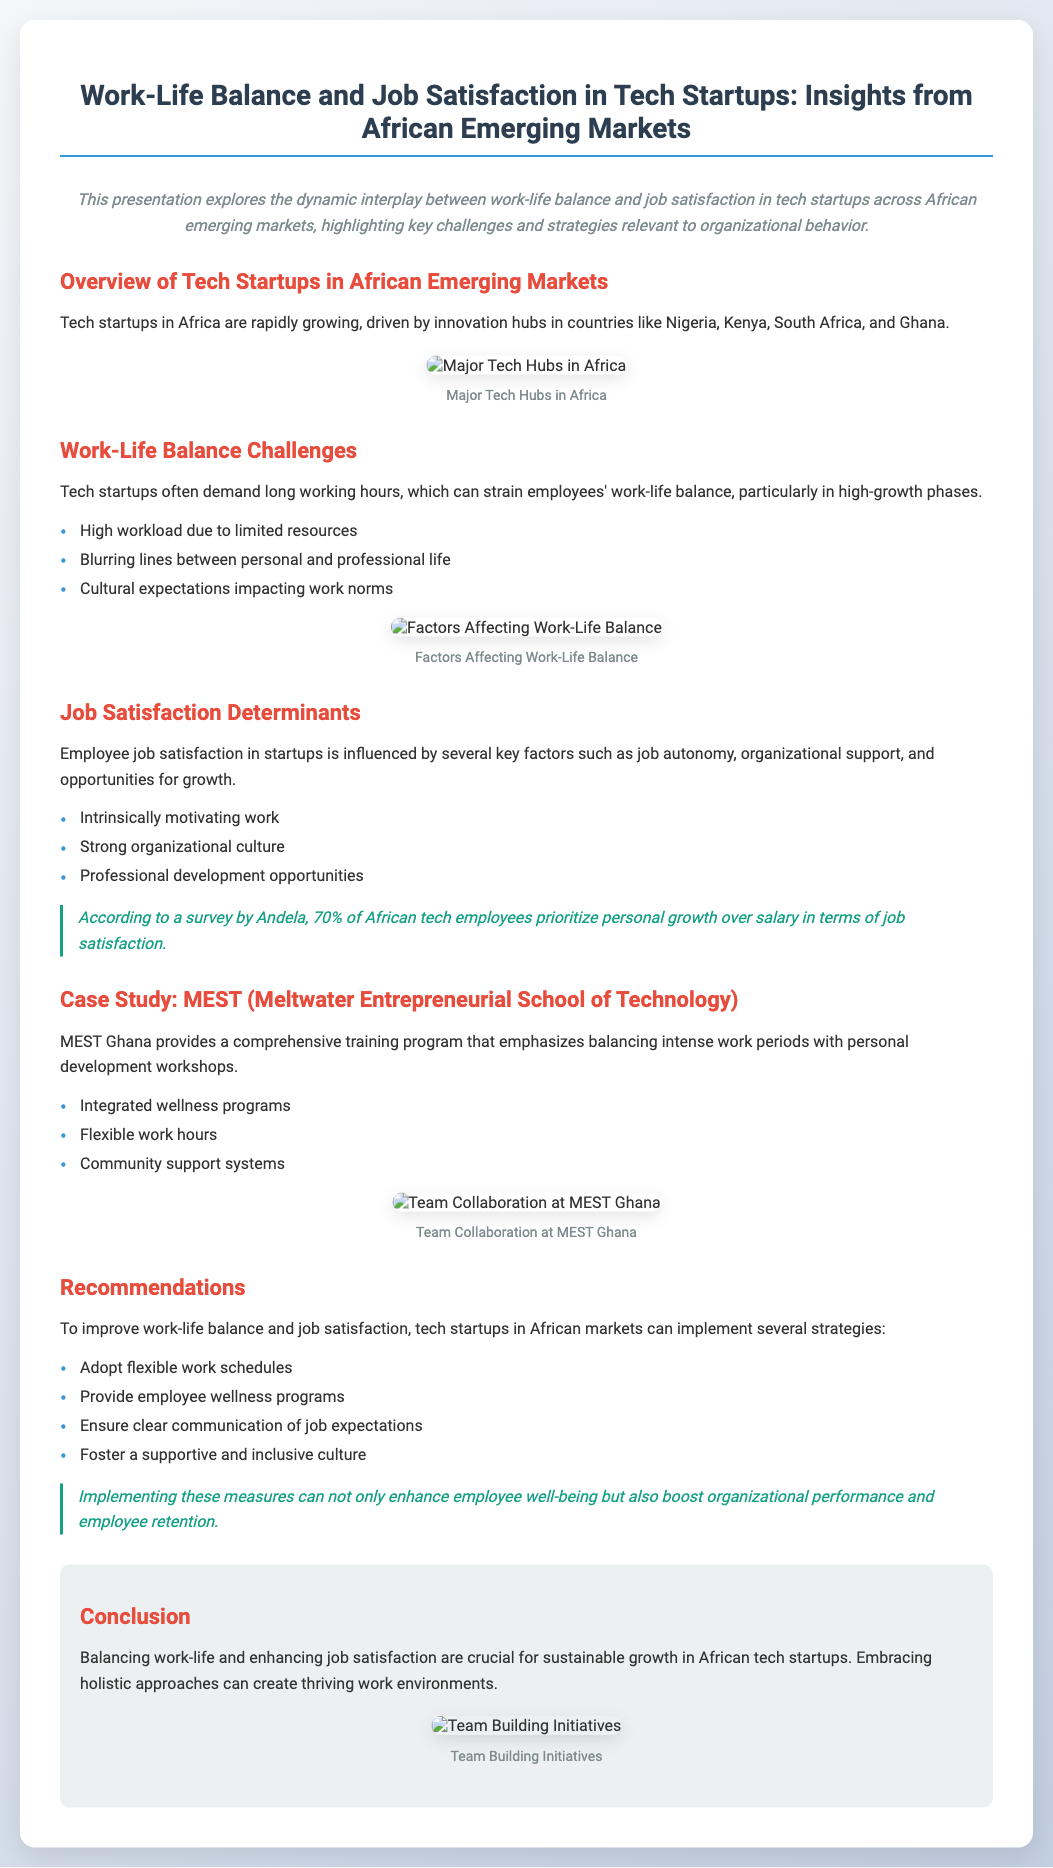What are the highlighted countries for tech startups? The countries highlighted for tech startups in Africa are Nigeria, Kenya, South Africa, and Ghana.
Answer: Nigeria, Kenya, South Africa, and Ghana What is a major work-life balance challenge? One major challenge mentioned is the blurring lines between personal and professional life.
Answer: Blurring lines between personal and professional life What percentage of African tech employees prioritize personal growth? The survey by Andela indicates that 70% of African tech employees prioritize personal growth over salary.
Answer: 70% What is a recommended strategy for tech startups? One recommended strategy is to adopt flexible work schedules.
Answer: Flexible work schedules What does the presentation conclude about work-life balance? The conclusion states that balancing work-life and enhancing job satisfaction are crucial for sustainable growth.
Answer: Crucial for sustainable growth What color is used for the main title in the slide? The main title is colored in a shade called #2c3e50.
Answer: #2c3e50 